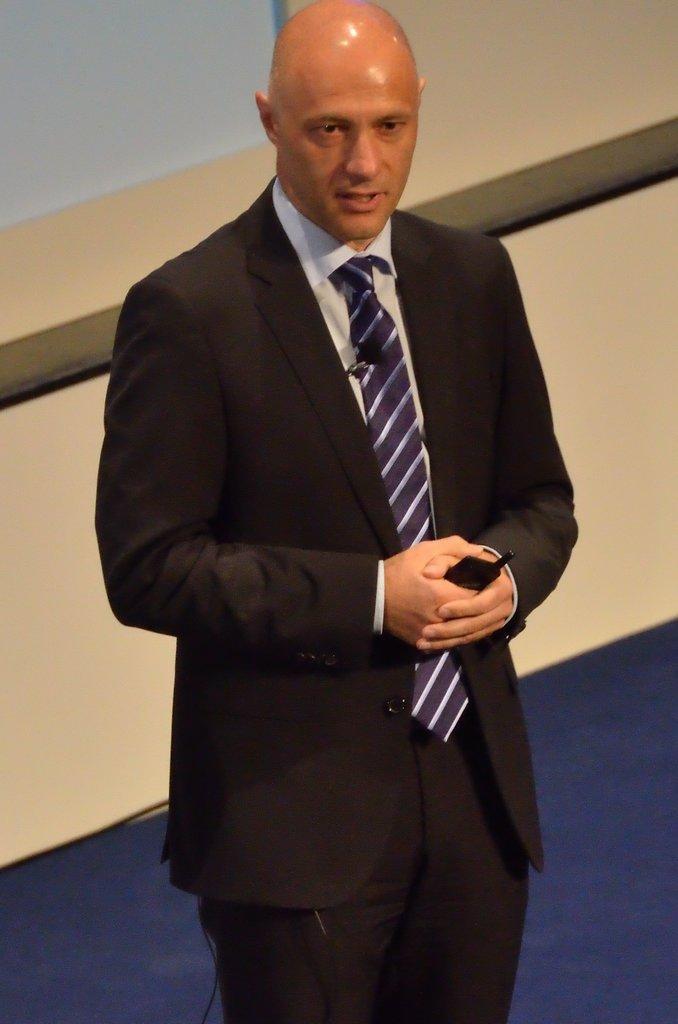How would you summarize this image in a sentence or two? In this image a person is standing on the floor. He is holding a mobile in his hand. He is wearing suit and tie. Behind him there is wall. 